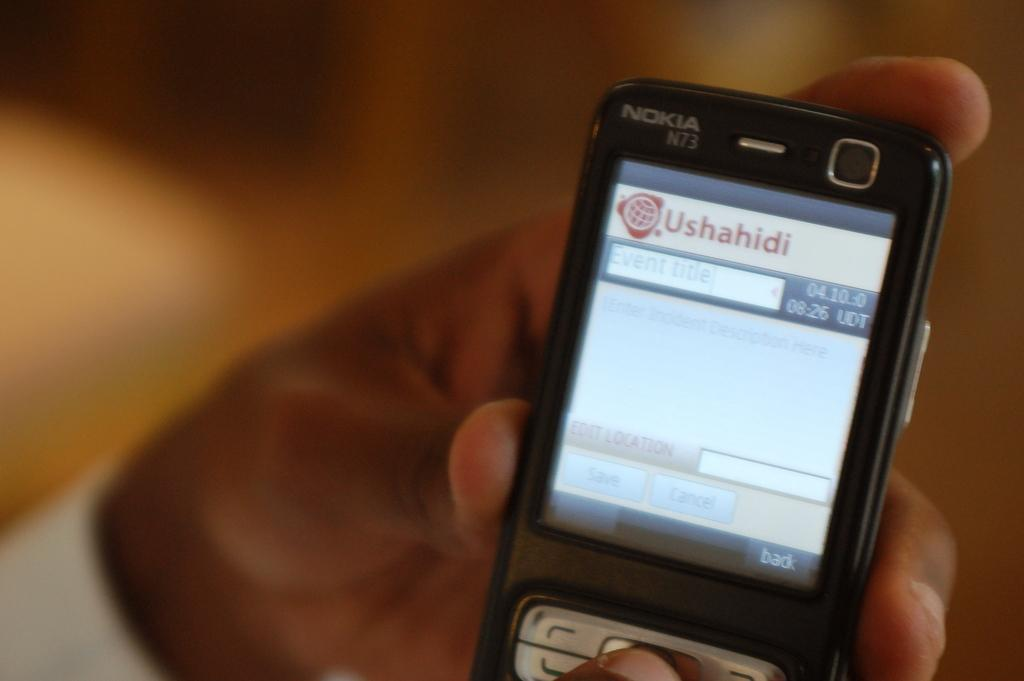<image>
Present a compact description of the photo's key features. A hand holds a Nokia N73 phone and the screen says Ushahidi. 